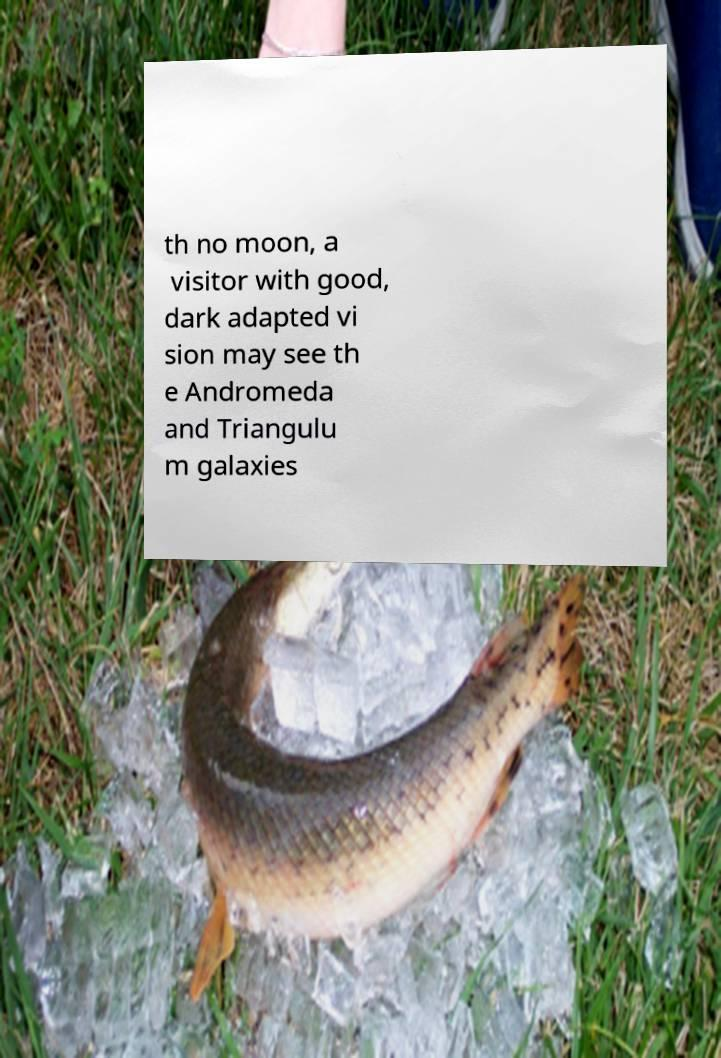Could you assist in decoding the text presented in this image and type it out clearly? th no moon, a visitor with good, dark adapted vi sion may see th e Andromeda and Triangulu m galaxies 